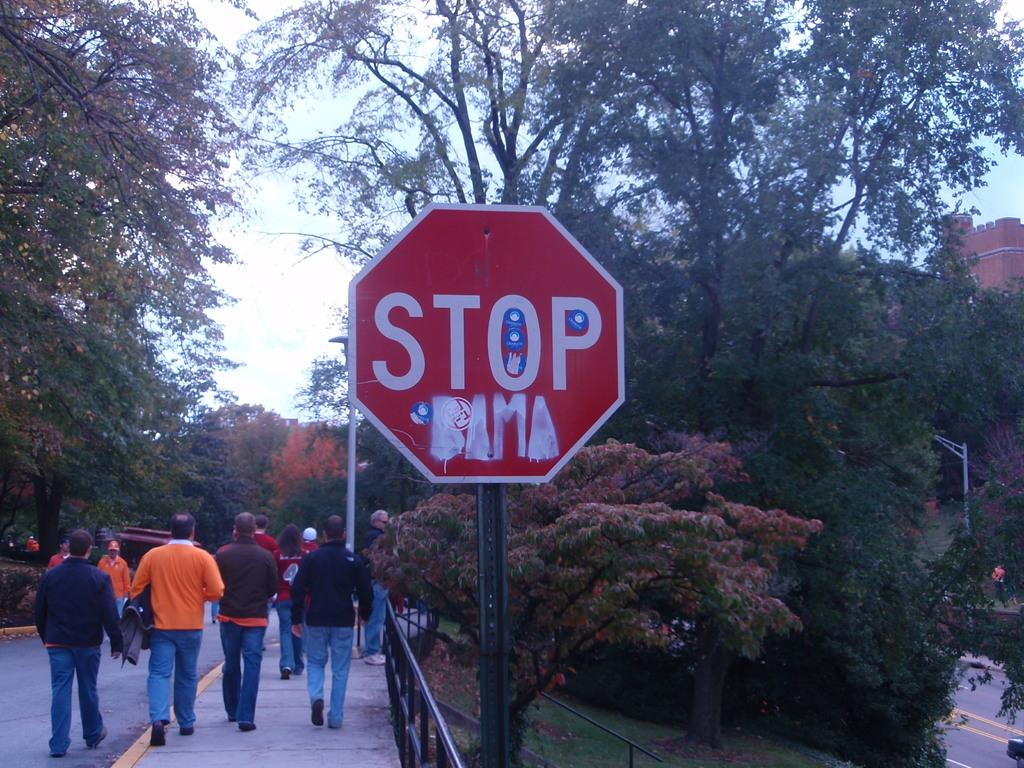Who needs to stop?
Offer a terse response. Bama. What does the sign tell you to do?
Offer a very short reply. Stop. 